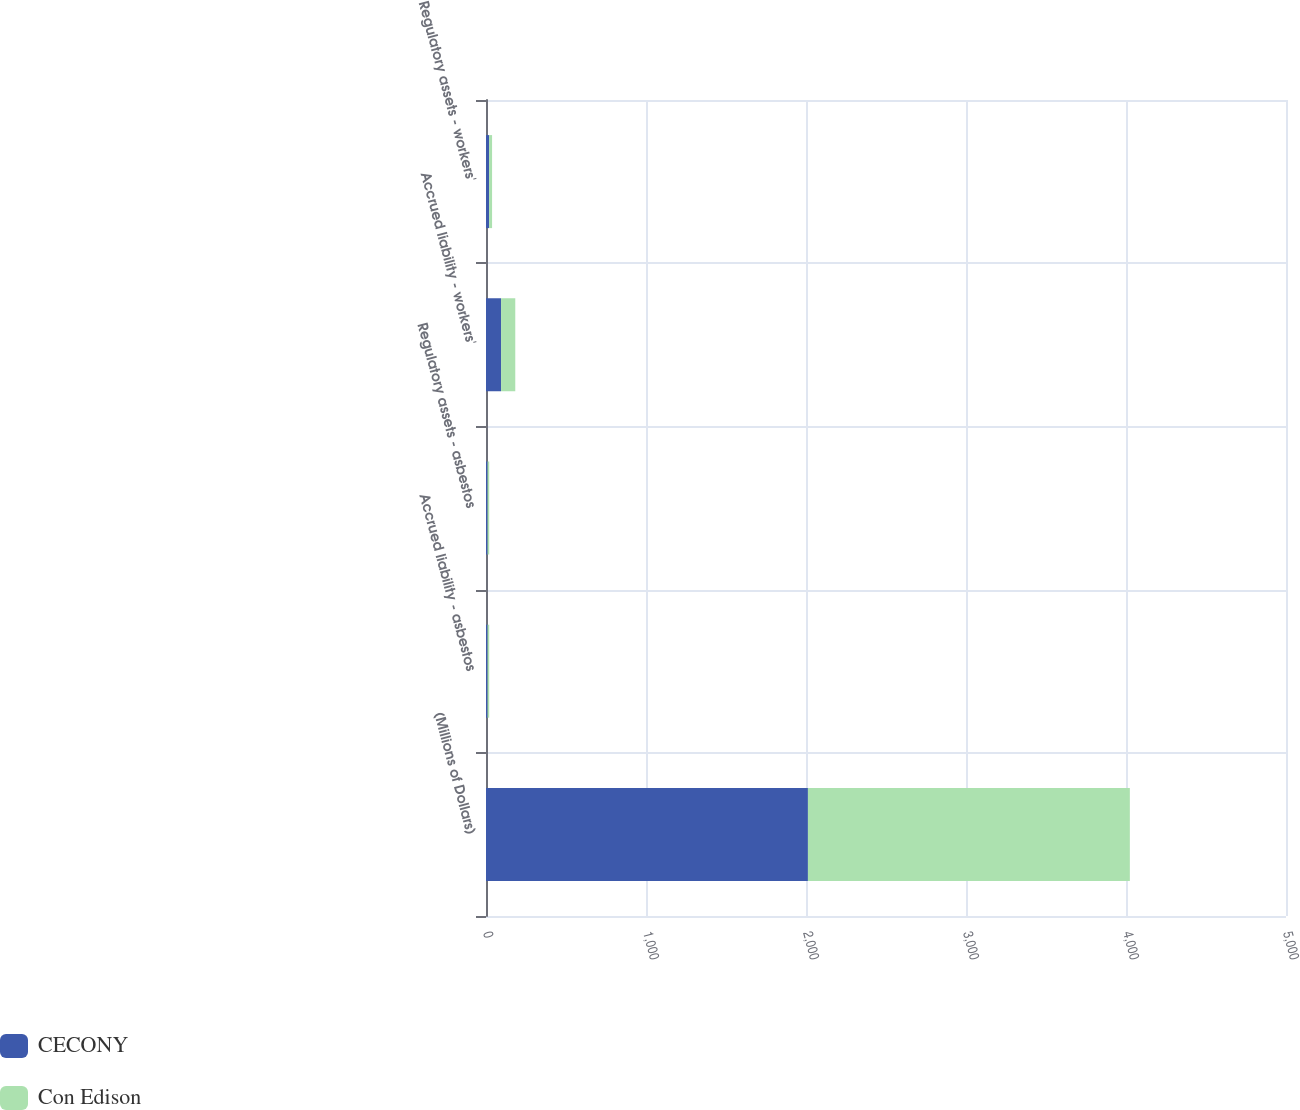<chart> <loc_0><loc_0><loc_500><loc_500><stacked_bar_chart><ecel><fcel>(Millions of Dollars)<fcel>Accrued liability - asbestos<fcel>Regulatory assets - asbestos<fcel>Accrued liability - workers'<fcel>Regulatory assets - workers'<nl><fcel>CECONY<fcel>2012<fcel>10<fcel>10<fcel>94<fcel>19<nl><fcel>Con Edison<fcel>2012<fcel>10<fcel>10<fcel>89<fcel>19<nl></chart> 